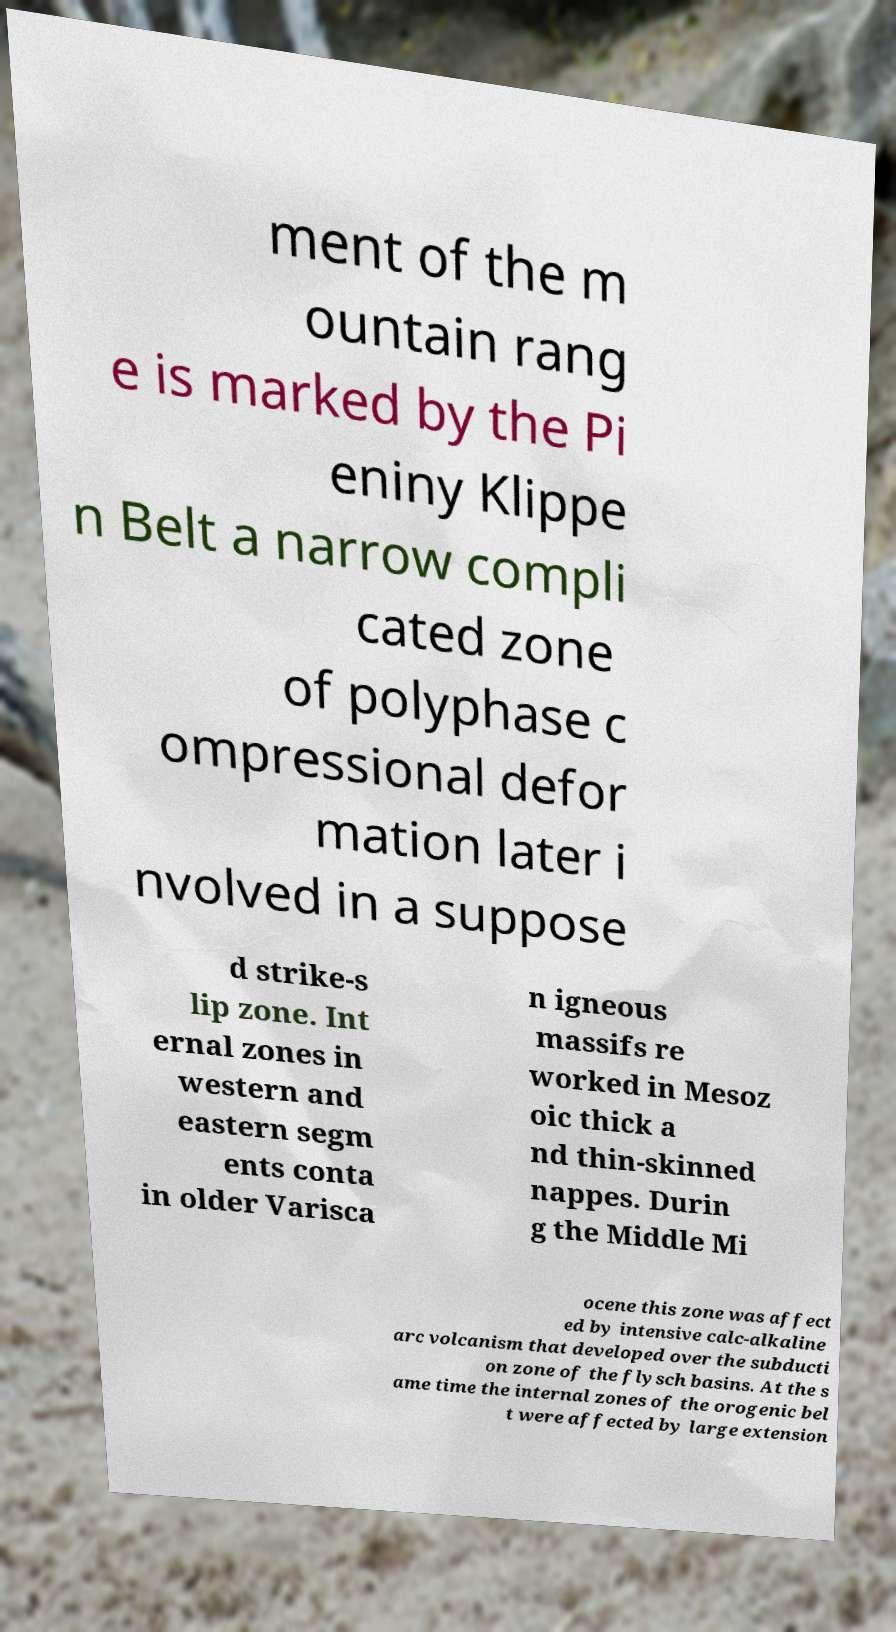Can you read and provide the text displayed in the image?This photo seems to have some interesting text. Can you extract and type it out for me? ment of the m ountain rang e is marked by the Pi eniny Klippe n Belt a narrow compli cated zone of polyphase c ompressional defor mation later i nvolved in a suppose d strike-s lip zone. Int ernal zones in western and eastern segm ents conta in older Varisca n igneous massifs re worked in Mesoz oic thick a nd thin-skinned nappes. Durin g the Middle Mi ocene this zone was affect ed by intensive calc-alkaline arc volcanism that developed over the subducti on zone of the flysch basins. At the s ame time the internal zones of the orogenic bel t were affected by large extension 